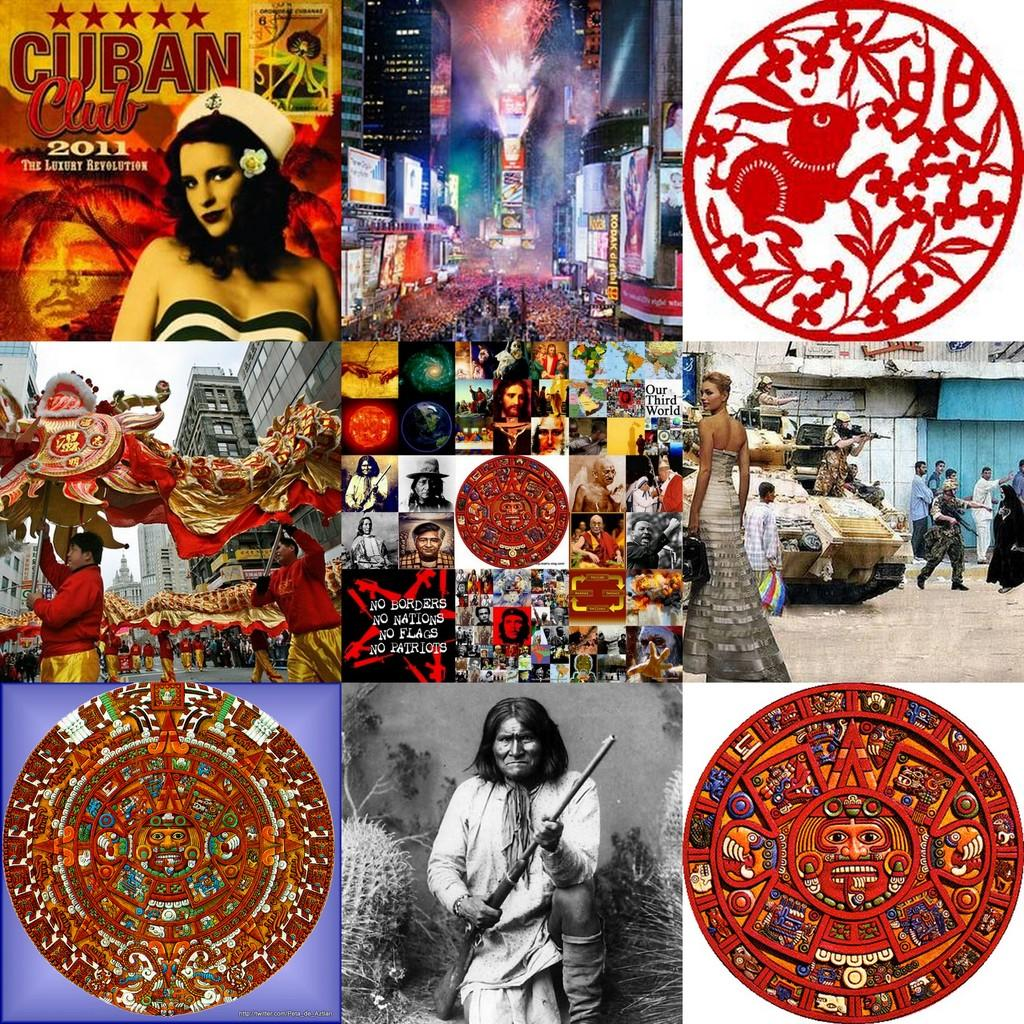What is the main subject of the image? The main subject of the image is a collection of many photos. Can you describe the person at the bottom of the image? There is a person holding a gun at the bottom of the image. What is the position of the other person in the image? There is another person at the top of the image. Are there any identifiable logos in the image? Yes, there are logos present in the image. What type of road can be seen in the image? There is no road present in the image; it features a collection of photos, a person holding a gun, and another person at the top, along with logos. 